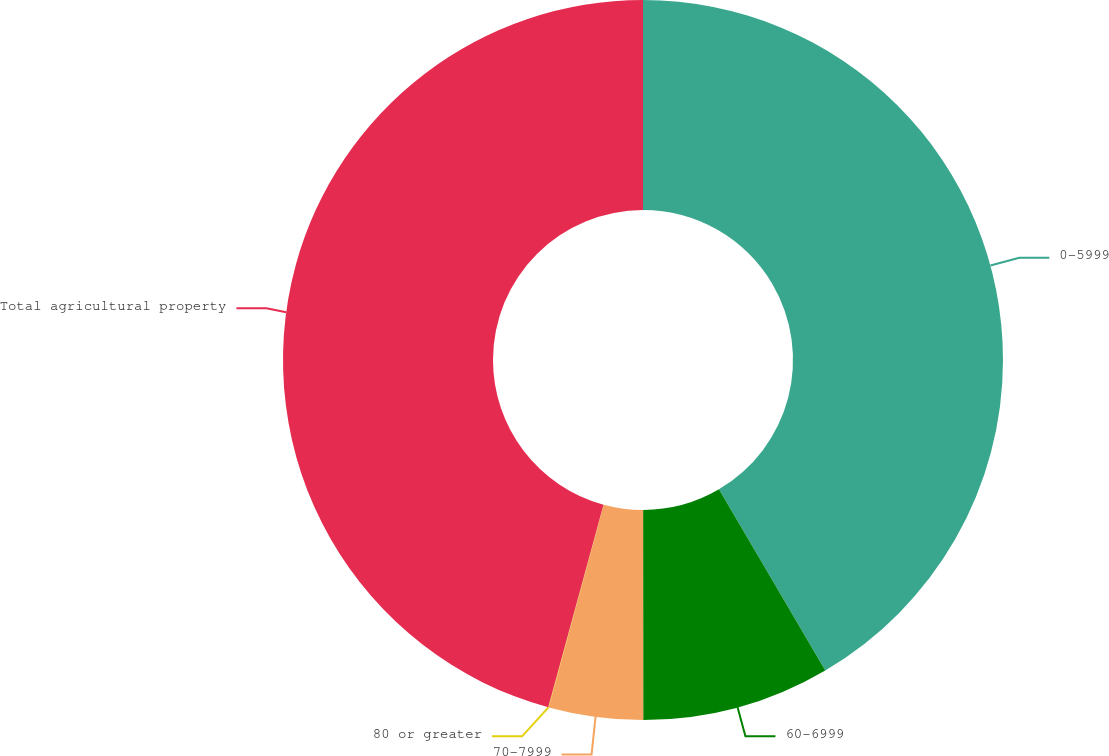<chart> <loc_0><loc_0><loc_500><loc_500><pie_chart><fcel>0-5999<fcel>60-6999<fcel>70-7999<fcel>80 or greater<fcel>Total agricultural property<nl><fcel>41.55%<fcel>8.44%<fcel>4.23%<fcel>0.02%<fcel>45.76%<nl></chart> 